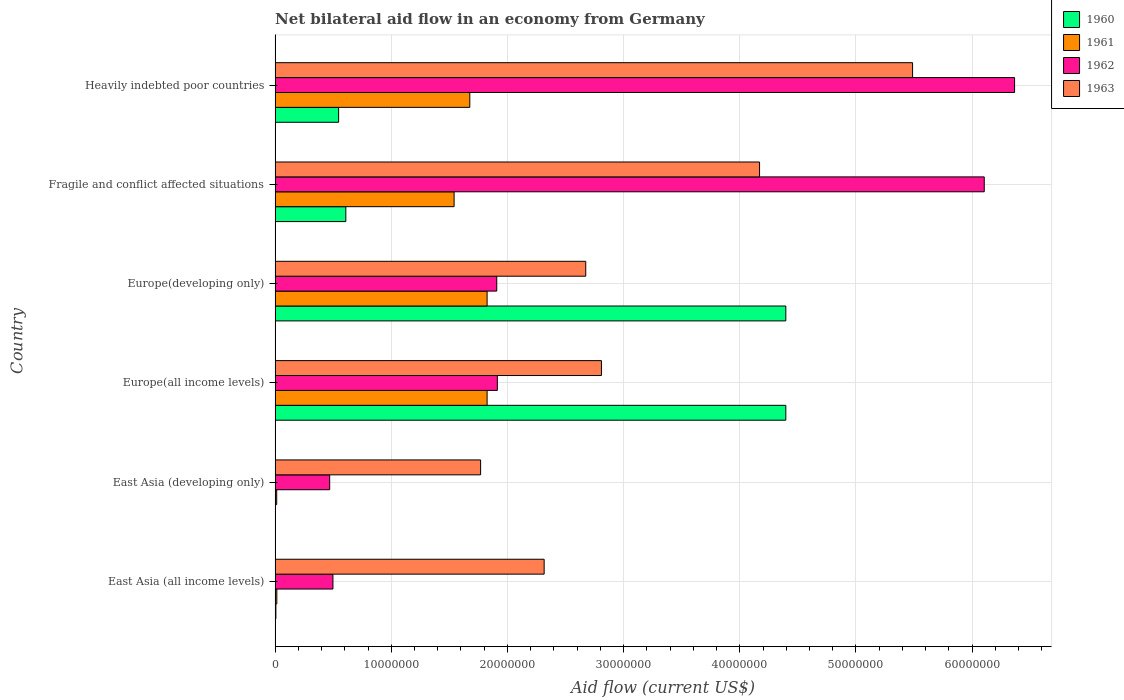Are the number of bars per tick equal to the number of legend labels?
Ensure brevity in your answer.  Yes. How many bars are there on the 2nd tick from the top?
Provide a succinct answer. 4. What is the label of the 3rd group of bars from the top?
Keep it short and to the point. Europe(developing only). In how many cases, is the number of bars for a given country not equal to the number of legend labels?
Keep it short and to the point. 0. Across all countries, what is the maximum net bilateral aid flow in 1963?
Your response must be concise. 5.49e+07. Across all countries, what is the minimum net bilateral aid flow in 1962?
Ensure brevity in your answer.  4.70e+06. In which country was the net bilateral aid flow in 1961 maximum?
Your response must be concise. Europe(all income levels). In which country was the net bilateral aid flow in 1961 minimum?
Make the answer very short. East Asia (developing only). What is the total net bilateral aid flow in 1963 in the graph?
Your answer should be very brief. 1.92e+08. What is the difference between the net bilateral aid flow in 1961 in East Asia (all income levels) and that in Heavily indebted poor countries?
Give a very brief answer. -1.66e+07. What is the difference between the net bilateral aid flow in 1962 in Heavily indebted poor countries and the net bilateral aid flow in 1960 in Fragile and conflict affected situations?
Provide a short and direct response. 5.76e+07. What is the average net bilateral aid flow in 1961 per country?
Provide a succinct answer. 1.15e+07. What is the difference between the net bilateral aid flow in 1962 and net bilateral aid flow in 1961 in East Asia (developing only)?
Offer a very short reply. 4.56e+06. In how many countries, is the net bilateral aid flow in 1963 greater than 42000000 US$?
Give a very brief answer. 1. What is the ratio of the net bilateral aid flow in 1963 in Europe(developing only) to that in Fragile and conflict affected situations?
Ensure brevity in your answer.  0.64. Is the net bilateral aid flow in 1962 in East Asia (all income levels) less than that in Europe(developing only)?
Your response must be concise. Yes. Is the difference between the net bilateral aid flow in 1962 in East Asia (all income levels) and Heavily indebted poor countries greater than the difference between the net bilateral aid flow in 1961 in East Asia (all income levels) and Heavily indebted poor countries?
Offer a terse response. No. What is the difference between the highest and the second highest net bilateral aid flow in 1960?
Your response must be concise. 0. What is the difference between the highest and the lowest net bilateral aid flow in 1962?
Make the answer very short. 5.90e+07. In how many countries, is the net bilateral aid flow in 1963 greater than the average net bilateral aid flow in 1963 taken over all countries?
Give a very brief answer. 2. Is the sum of the net bilateral aid flow in 1962 in East Asia (developing only) and Europe(developing only) greater than the maximum net bilateral aid flow in 1963 across all countries?
Offer a terse response. No. What does the 4th bar from the top in Fragile and conflict affected situations represents?
Your response must be concise. 1960. What does the 2nd bar from the bottom in East Asia (developing only) represents?
Offer a very short reply. 1961. Is it the case that in every country, the sum of the net bilateral aid flow in 1962 and net bilateral aid flow in 1961 is greater than the net bilateral aid flow in 1963?
Your answer should be compact. No. How many countries are there in the graph?
Offer a terse response. 6. What is the difference between two consecutive major ticks on the X-axis?
Offer a very short reply. 1.00e+07. How many legend labels are there?
Provide a succinct answer. 4. How are the legend labels stacked?
Offer a very short reply. Vertical. What is the title of the graph?
Make the answer very short. Net bilateral aid flow in an economy from Germany. Does "1995" appear as one of the legend labels in the graph?
Your response must be concise. No. What is the Aid flow (current US$) of 1961 in East Asia (all income levels)?
Give a very brief answer. 1.50e+05. What is the Aid flow (current US$) in 1962 in East Asia (all income levels)?
Ensure brevity in your answer.  4.98e+06. What is the Aid flow (current US$) of 1963 in East Asia (all income levels)?
Give a very brief answer. 2.32e+07. What is the Aid flow (current US$) of 1960 in East Asia (developing only)?
Offer a terse response. 3.00e+04. What is the Aid flow (current US$) of 1962 in East Asia (developing only)?
Your answer should be compact. 4.70e+06. What is the Aid flow (current US$) of 1963 in East Asia (developing only)?
Your response must be concise. 1.77e+07. What is the Aid flow (current US$) in 1960 in Europe(all income levels)?
Provide a short and direct response. 4.40e+07. What is the Aid flow (current US$) of 1961 in Europe(all income levels)?
Your answer should be compact. 1.82e+07. What is the Aid flow (current US$) of 1962 in Europe(all income levels)?
Make the answer very short. 1.91e+07. What is the Aid flow (current US$) of 1963 in Europe(all income levels)?
Make the answer very short. 2.81e+07. What is the Aid flow (current US$) in 1960 in Europe(developing only)?
Provide a succinct answer. 4.40e+07. What is the Aid flow (current US$) in 1961 in Europe(developing only)?
Keep it short and to the point. 1.82e+07. What is the Aid flow (current US$) of 1962 in Europe(developing only)?
Offer a very short reply. 1.91e+07. What is the Aid flow (current US$) of 1963 in Europe(developing only)?
Keep it short and to the point. 2.67e+07. What is the Aid flow (current US$) of 1960 in Fragile and conflict affected situations?
Your response must be concise. 6.09e+06. What is the Aid flow (current US$) in 1961 in Fragile and conflict affected situations?
Your answer should be compact. 1.54e+07. What is the Aid flow (current US$) of 1962 in Fragile and conflict affected situations?
Offer a very short reply. 6.10e+07. What is the Aid flow (current US$) in 1963 in Fragile and conflict affected situations?
Offer a very short reply. 4.17e+07. What is the Aid flow (current US$) of 1960 in Heavily indebted poor countries?
Your answer should be compact. 5.47e+06. What is the Aid flow (current US$) in 1961 in Heavily indebted poor countries?
Your answer should be very brief. 1.68e+07. What is the Aid flow (current US$) of 1962 in Heavily indebted poor countries?
Keep it short and to the point. 6.36e+07. What is the Aid flow (current US$) of 1963 in Heavily indebted poor countries?
Your response must be concise. 5.49e+07. Across all countries, what is the maximum Aid flow (current US$) of 1960?
Offer a very short reply. 4.40e+07. Across all countries, what is the maximum Aid flow (current US$) of 1961?
Your answer should be very brief. 1.82e+07. Across all countries, what is the maximum Aid flow (current US$) of 1962?
Give a very brief answer. 6.36e+07. Across all countries, what is the maximum Aid flow (current US$) of 1963?
Your answer should be very brief. 5.49e+07. Across all countries, what is the minimum Aid flow (current US$) in 1962?
Offer a terse response. 4.70e+06. Across all countries, what is the minimum Aid flow (current US$) in 1963?
Make the answer very short. 1.77e+07. What is the total Aid flow (current US$) in 1960 in the graph?
Give a very brief answer. 9.96e+07. What is the total Aid flow (current US$) of 1961 in the graph?
Provide a succinct answer. 6.90e+07. What is the total Aid flow (current US$) in 1962 in the graph?
Your response must be concise. 1.73e+08. What is the total Aid flow (current US$) in 1963 in the graph?
Keep it short and to the point. 1.92e+08. What is the difference between the Aid flow (current US$) of 1960 in East Asia (all income levels) and that in East Asia (developing only)?
Give a very brief answer. 4.00e+04. What is the difference between the Aid flow (current US$) in 1962 in East Asia (all income levels) and that in East Asia (developing only)?
Give a very brief answer. 2.80e+05. What is the difference between the Aid flow (current US$) of 1963 in East Asia (all income levels) and that in East Asia (developing only)?
Give a very brief answer. 5.47e+06. What is the difference between the Aid flow (current US$) of 1960 in East Asia (all income levels) and that in Europe(all income levels)?
Your response must be concise. -4.39e+07. What is the difference between the Aid flow (current US$) of 1961 in East Asia (all income levels) and that in Europe(all income levels)?
Your answer should be very brief. -1.81e+07. What is the difference between the Aid flow (current US$) of 1962 in East Asia (all income levels) and that in Europe(all income levels)?
Make the answer very short. -1.42e+07. What is the difference between the Aid flow (current US$) of 1963 in East Asia (all income levels) and that in Europe(all income levels)?
Provide a short and direct response. -4.93e+06. What is the difference between the Aid flow (current US$) in 1960 in East Asia (all income levels) and that in Europe(developing only)?
Give a very brief answer. -4.39e+07. What is the difference between the Aid flow (current US$) of 1961 in East Asia (all income levels) and that in Europe(developing only)?
Your answer should be compact. -1.81e+07. What is the difference between the Aid flow (current US$) of 1962 in East Asia (all income levels) and that in Europe(developing only)?
Provide a succinct answer. -1.41e+07. What is the difference between the Aid flow (current US$) in 1963 in East Asia (all income levels) and that in Europe(developing only)?
Offer a terse response. -3.58e+06. What is the difference between the Aid flow (current US$) in 1960 in East Asia (all income levels) and that in Fragile and conflict affected situations?
Your response must be concise. -6.02e+06. What is the difference between the Aid flow (current US$) in 1961 in East Asia (all income levels) and that in Fragile and conflict affected situations?
Your response must be concise. -1.53e+07. What is the difference between the Aid flow (current US$) of 1962 in East Asia (all income levels) and that in Fragile and conflict affected situations?
Ensure brevity in your answer.  -5.61e+07. What is the difference between the Aid flow (current US$) of 1963 in East Asia (all income levels) and that in Fragile and conflict affected situations?
Your answer should be compact. -1.85e+07. What is the difference between the Aid flow (current US$) in 1960 in East Asia (all income levels) and that in Heavily indebted poor countries?
Your answer should be very brief. -5.40e+06. What is the difference between the Aid flow (current US$) in 1961 in East Asia (all income levels) and that in Heavily indebted poor countries?
Ensure brevity in your answer.  -1.66e+07. What is the difference between the Aid flow (current US$) of 1962 in East Asia (all income levels) and that in Heavily indebted poor countries?
Provide a succinct answer. -5.87e+07. What is the difference between the Aid flow (current US$) of 1963 in East Asia (all income levels) and that in Heavily indebted poor countries?
Your answer should be very brief. -3.17e+07. What is the difference between the Aid flow (current US$) of 1960 in East Asia (developing only) and that in Europe(all income levels)?
Your answer should be very brief. -4.39e+07. What is the difference between the Aid flow (current US$) in 1961 in East Asia (developing only) and that in Europe(all income levels)?
Your answer should be very brief. -1.81e+07. What is the difference between the Aid flow (current US$) of 1962 in East Asia (developing only) and that in Europe(all income levels)?
Make the answer very short. -1.44e+07. What is the difference between the Aid flow (current US$) in 1963 in East Asia (developing only) and that in Europe(all income levels)?
Keep it short and to the point. -1.04e+07. What is the difference between the Aid flow (current US$) of 1960 in East Asia (developing only) and that in Europe(developing only)?
Provide a short and direct response. -4.39e+07. What is the difference between the Aid flow (current US$) of 1961 in East Asia (developing only) and that in Europe(developing only)?
Offer a very short reply. -1.81e+07. What is the difference between the Aid flow (current US$) of 1962 in East Asia (developing only) and that in Europe(developing only)?
Provide a short and direct response. -1.44e+07. What is the difference between the Aid flow (current US$) in 1963 in East Asia (developing only) and that in Europe(developing only)?
Offer a terse response. -9.05e+06. What is the difference between the Aid flow (current US$) in 1960 in East Asia (developing only) and that in Fragile and conflict affected situations?
Your answer should be compact. -6.06e+06. What is the difference between the Aid flow (current US$) of 1961 in East Asia (developing only) and that in Fragile and conflict affected situations?
Provide a succinct answer. -1.53e+07. What is the difference between the Aid flow (current US$) in 1962 in East Asia (developing only) and that in Fragile and conflict affected situations?
Keep it short and to the point. -5.63e+07. What is the difference between the Aid flow (current US$) of 1963 in East Asia (developing only) and that in Fragile and conflict affected situations?
Ensure brevity in your answer.  -2.40e+07. What is the difference between the Aid flow (current US$) of 1960 in East Asia (developing only) and that in Heavily indebted poor countries?
Provide a short and direct response. -5.44e+06. What is the difference between the Aid flow (current US$) of 1961 in East Asia (developing only) and that in Heavily indebted poor countries?
Provide a succinct answer. -1.66e+07. What is the difference between the Aid flow (current US$) of 1962 in East Asia (developing only) and that in Heavily indebted poor countries?
Ensure brevity in your answer.  -5.90e+07. What is the difference between the Aid flow (current US$) in 1963 in East Asia (developing only) and that in Heavily indebted poor countries?
Provide a succinct answer. -3.72e+07. What is the difference between the Aid flow (current US$) of 1961 in Europe(all income levels) and that in Europe(developing only)?
Keep it short and to the point. 0. What is the difference between the Aid flow (current US$) of 1962 in Europe(all income levels) and that in Europe(developing only)?
Your answer should be compact. 5.00e+04. What is the difference between the Aid flow (current US$) of 1963 in Europe(all income levels) and that in Europe(developing only)?
Your response must be concise. 1.35e+06. What is the difference between the Aid flow (current US$) in 1960 in Europe(all income levels) and that in Fragile and conflict affected situations?
Provide a succinct answer. 3.79e+07. What is the difference between the Aid flow (current US$) of 1961 in Europe(all income levels) and that in Fragile and conflict affected situations?
Your answer should be very brief. 2.84e+06. What is the difference between the Aid flow (current US$) of 1962 in Europe(all income levels) and that in Fragile and conflict affected situations?
Offer a terse response. -4.19e+07. What is the difference between the Aid flow (current US$) in 1963 in Europe(all income levels) and that in Fragile and conflict affected situations?
Offer a very short reply. -1.36e+07. What is the difference between the Aid flow (current US$) in 1960 in Europe(all income levels) and that in Heavily indebted poor countries?
Provide a succinct answer. 3.85e+07. What is the difference between the Aid flow (current US$) in 1961 in Europe(all income levels) and that in Heavily indebted poor countries?
Provide a short and direct response. 1.49e+06. What is the difference between the Aid flow (current US$) of 1962 in Europe(all income levels) and that in Heavily indebted poor countries?
Ensure brevity in your answer.  -4.45e+07. What is the difference between the Aid flow (current US$) of 1963 in Europe(all income levels) and that in Heavily indebted poor countries?
Give a very brief answer. -2.68e+07. What is the difference between the Aid flow (current US$) of 1960 in Europe(developing only) and that in Fragile and conflict affected situations?
Ensure brevity in your answer.  3.79e+07. What is the difference between the Aid flow (current US$) in 1961 in Europe(developing only) and that in Fragile and conflict affected situations?
Ensure brevity in your answer.  2.84e+06. What is the difference between the Aid flow (current US$) in 1962 in Europe(developing only) and that in Fragile and conflict affected situations?
Offer a very short reply. -4.20e+07. What is the difference between the Aid flow (current US$) in 1963 in Europe(developing only) and that in Fragile and conflict affected situations?
Offer a terse response. -1.50e+07. What is the difference between the Aid flow (current US$) of 1960 in Europe(developing only) and that in Heavily indebted poor countries?
Make the answer very short. 3.85e+07. What is the difference between the Aid flow (current US$) of 1961 in Europe(developing only) and that in Heavily indebted poor countries?
Give a very brief answer. 1.49e+06. What is the difference between the Aid flow (current US$) in 1962 in Europe(developing only) and that in Heavily indebted poor countries?
Keep it short and to the point. -4.46e+07. What is the difference between the Aid flow (current US$) in 1963 in Europe(developing only) and that in Heavily indebted poor countries?
Provide a short and direct response. -2.81e+07. What is the difference between the Aid flow (current US$) of 1960 in Fragile and conflict affected situations and that in Heavily indebted poor countries?
Offer a terse response. 6.20e+05. What is the difference between the Aid flow (current US$) of 1961 in Fragile and conflict affected situations and that in Heavily indebted poor countries?
Keep it short and to the point. -1.35e+06. What is the difference between the Aid flow (current US$) in 1962 in Fragile and conflict affected situations and that in Heavily indebted poor countries?
Give a very brief answer. -2.61e+06. What is the difference between the Aid flow (current US$) of 1963 in Fragile and conflict affected situations and that in Heavily indebted poor countries?
Make the answer very short. -1.32e+07. What is the difference between the Aid flow (current US$) of 1960 in East Asia (all income levels) and the Aid flow (current US$) of 1962 in East Asia (developing only)?
Provide a succinct answer. -4.63e+06. What is the difference between the Aid flow (current US$) in 1960 in East Asia (all income levels) and the Aid flow (current US$) in 1963 in East Asia (developing only)?
Your answer should be compact. -1.76e+07. What is the difference between the Aid flow (current US$) in 1961 in East Asia (all income levels) and the Aid flow (current US$) in 1962 in East Asia (developing only)?
Provide a succinct answer. -4.55e+06. What is the difference between the Aid flow (current US$) in 1961 in East Asia (all income levels) and the Aid flow (current US$) in 1963 in East Asia (developing only)?
Make the answer very short. -1.75e+07. What is the difference between the Aid flow (current US$) of 1962 in East Asia (all income levels) and the Aid flow (current US$) of 1963 in East Asia (developing only)?
Your response must be concise. -1.27e+07. What is the difference between the Aid flow (current US$) of 1960 in East Asia (all income levels) and the Aid flow (current US$) of 1961 in Europe(all income levels)?
Make the answer very short. -1.82e+07. What is the difference between the Aid flow (current US$) in 1960 in East Asia (all income levels) and the Aid flow (current US$) in 1962 in Europe(all income levels)?
Give a very brief answer. -1.91e+07. What is the difference between the Aid flow (current US$) in 1960 in East Asia (all income levels) and the Aid flow (current US$) in 1963 in Europe(all income levels)?
Make the answer very short. -2.80e+07. What is the difference between the Aid flow (current US$) of 1961 in East Asia (all income levels) and the Aid flow (current US$) of 1962 in Europe(all income levels)?
Make the answer very short. -1.90e+07. What is the difference between the Aid flow (current US$) in 1961 in East Asia (all income levels) and the Aid flow (current US$) in 1963 in Europe(all income levels)?
Ensure brevity in your answer.  -2.79e+07. What is the difference between the Aid flow (current US$) of 1962 in East Asia (all income levels) and the Aid flow (current US$) of 1963 in Europe(all income levels)?
Offer a terse response. -2.31e+07. What is the difference between the Aid flow (current US$) of 1960 in East Asia (all income levels) and the Aid flow (current US$) of 1961 in Europe(developing only)?
Keep it short and to the point. -1.82e+07. What is the difference between the Aid flow (current US$) of 1960 in East Asia (all income levels) and the Aid flow (current US$) of 1962 in Europe(developing only)?
Your answer should be very brief. -1.90e+07. What is the difference between the Aid flow (current US$) in 1960 in East Asia (all income levels) and the Aid flow (current US$) in 1963 in Europe(developing only)?
Ensure brevity in your answer.  -2.67e+07. What is the difference between the Aid flow (current US$) of 1961 in East Asia (all income levels) and the Aid flow (current US$) of 1962 in Europe(developing only)?
Provide a short and direct response. -1.89e+07. What is the difference between the Aid flow (current US$) in 1961 in East Asia (all income levels) and the Aid flow (current US$) in 1963 in Europe(developing only)?
Ensure brevity in your answer.  -2.66e+07. What is the difference between the Aid flow (current US$) of 1962 in East Asia (all income levels) and the Aid flow (current US$) of 1963 in Europe(developing only)?
Keep it short and to the point. -2.18e+07. What is the difference between the Aid flow (current US$) in 1960 in East Asia (all income levels) and the Aid flow (current US$) in 1961 in Fragile and conflict affected situations?
Your answer should be very brief. -1.53e+07. What is the difference between the Aid flow (current US$) of 1960 in East Asia (all income levels) and the Aid flow (current US$) of 1962 in Fragile and conflict affected situations?
Give a very brief answer. -6.10e+07. What is the difference between the Aid flow (current US$) in 1960 in East Asia (all income levels) and the Aid flow (current US$) in 1963 in Fragile and conflict affected situations?
Your answer should be very brief. -4.16e+07. What is the difference between the Aid flow (current US$) of 1961 in East Asia (all income levels) and the Aid flow (current US$) of 1962 in Fragile and conflict affected situations?
Keep it short and to the point. -6.09e+07. What is the difference between the Aid flow (current US$) of 1961 in East Asia (all income levels) and the Aid flow (current US$) of 1963 in Fragile and conflict affected situations?
Your answer should be compact. -4.16e+07. What is the difference between the Aid flow (current US$) of 1962 in East Asia (all income levels) and the Aid flow (current US$) of 1963 in Fragile and conflict affected situations?
Make the answer very short. -3.67e+07. What is the difference between the Aid flow (current US$) in 1960 in East Asia (all income levels) and the Aid flow (current US$) in 1961 in Heavily indebted poor countries?
Your answer should be compact. -1.67e+07. What is the difference between the Aid flow (current US$) of 1960 in East Asia (all income levels) and the Aid flow (current US$) of 1962 in Heavily indebted poor countries?
Provide a short and direct response. -6.36e+07. What is the difference between the Aid flow (current US$) in 1960 in East Asia (all income levels) and the Aid flow (current US$) in 1963 in Heavily indebted poor countries?
Ensure brevity in your answer.  -5.48e+07. What is the difference between the Aid flow (current US$) in 1961 in East Asia (all income levels) and the Aid flow (current US$) in 1962 in Heavily indebted poor countries?
Provide a short and direct response. -6.35e+07. What is the difference between the Aid flow (current US$) of 1961 in East Asia (all income levels) and the Aid flow (current US$) of 1963 in Heavily indebted poor countries?
Your answer should be compact. -5.47e+07. What is the difference between the Aid flow (current US$) of 1962 in East Asia (all income levels) and the Aid flow (current US$) of 1963 in Heavily indebted poor countries?
Make the answer very short. -4.99e+07. What is the difference between the Aid flow (current US$) in 1960 in East Asia (developing only) and the Aid flow (current US$) in 1961 in Europe(all income levels)?
Keep it short and to the point. -1.82e+07. What is the difference between the Aid flow (current US$) of 1960 in East Asia (developing only) and the Aid flow (current US$) of 1962 in Europe(all income levels)?
Your response must be concise. -1.91e+07. What is the difference between the Aid flow (current US$) of 1960 in East Asia (developing only) and the Aid flow (current US$) of 1963 in Europe(all income levels)?
Your answer should be very brief. -2.81e+07. What is the difference between the Aid flow (current US$) of 1961 in East Asia (developing only) and the Aid flow (current US$) of 1962 in Europe(all income levels)?
Provide a succinct answer. -1.90e+07. What is the difference between the Aid flow (current US$) in 1961 in East Asia (developing only) and the Aid flow (current US$) in 1963 in Europe(all income levels)?
Your answer should be compact. -2.80e+07. What is the difference between the Aid flow (current US$) of 1962 in East Asia (developing only) and the Aid flow (current US$) of 1963 in Europe(all income levels)?
Your answer should be very brief. -2.34e+07. What is the difference between the Aid flow (current US$) in 1960 in East Asia (developing only) and the Aid flow (current US$) in 1961 in Europe(developing only)?
Offer a very short reply. -1.82e+07. What is the difference between the Aid flow (current US$) in 1960 in East Asia (developing only) and the Aid flow (current US$) in 1962 in Europe(developing only)?
Keep it short and to the point. -1.90e+07. What is the difference between the Aid flow (current US$) of 1960 in East Asia (developing only) and the Aid flow (current US$) of 1963 in Europe(developing only)?
Make the answer very short. -2.67e+07. What is the difference between the Aid flow (current US$) of 1961 in East Asia (developing only) and the Aid flow (current US$) of 1962 in Europe(developing only)?
Offer a terse response. -1.89e+07. What is the difference between the Aid flow (current US$) in 1961 in East Asia (developing only) and the Aid flow (current US$) in 1963 in Europe(developing only)?
Your answer should be compact. -2.66e+07. What is the difference between the Aid flow (current US$) in 1962 in East Asia (developing only) and the Aid flow (current US$) in 1963 in Europe(developing only)?
Your response must be concise. -2.20e+07. What is the difference between the Aid flow (current US$) in 1960 in East Asia (developing only) and the Aid flow (current US$) in 1961 in Fragile and conflict affected situations?
Ensure brevity in your answer.  -1.54e+07. What is the difference between the Aid flow (current US$) in 1960 in East Asia (developing only) and the Aid flow (current US$) in 1962 in Fragile and conflict affected situations?
Provide a short and direct response. -6.10e+07. What is the difference between the Aid flow (current US$) of 1960 in East Asia (developing only) and the Aid flow (current US$) of 1963 in Fragile and conflict affected situations?
Offer a very short reply. -4.17e+07. What is the difference between the Aid flow (current US$) in 1961 in East Asia (developing only) and the Aid flow (current US$) in 1962 in Fragile and conflict affected situations?
Offer a terse response. -6.09e+07. What is the difference between the Aid flow (current US$) of 1961 in East Asia (developing only) and the Aid flow (current US$) of 1963 in Fragile and conflict affected situations?
Offer a terse response. -4.16e+07. What is the difference between the Aid flow (current US$) in 1962 in East Asia (developing only) and the Aid flow (current US$) in 1963 in Fragile and conflict affected situations?
Keep it short and to the point. -3.70e+07. What is the difference between the Aid flow (current US$) of 1960 in East Asia (developing only) and the Aid flow (current US$) of 1961 in Heavily indebted poor countries?
Ensure brevity in your answer.  -1.67e+07. What is the difference between the Aid flow (current US$) of 1960 in East Asia (developing only) and the Aid flow (current US$) of 1962 in Heavily indebted poor countries?
Provide a succinct answer. -6.36e+07. What is the difference between the Aid flow (current US$) in 1960 in East Asia (developing only) and the Aid flow (current US$) in 1963 in Heavily indebted poor countries?
Your answer should be very brief. -5.48e+07. What is the difference between the Aid flow (current US$) in 1961 in East Asia (developing only) and the Aid flow (current US$) in 1962 in Heavily indebted poor countries?
Provide a succinct answer. -6.35e+07. What is the difference between the Aid flow (current US$) of 1961 in East Asia (developing only) and the Aid flow (current US$) of 1963 in Heavily indebted poor countries?
Offer a very short reply. -5.47e+07. What is the difference between the Aid flow (current US$) in 1962 in East Asia (developing only) and the Aid flow (current US$) in 1963 in Heavily indebted poor countries?
Give a very brief answer. -5.02e+07. What is the difference between the Aid flow (current US$) in 1960 in Europe(all income levels) and the Aid flow (current US$) in 1961 in Europe(developing only)?
Provide a succinct answer. 2.57e+07. What is the difference between the Aid flow (current US$) in 1960 in Europe(all income levels) and the Aid flow (current US$) in 1962 in Europe(developing only)?
Your response must be concise. 2.49e+07. What is the difference between the Aid flow (current US$) of 1960 in Europe(all income levels) and the Aid flow (current US$) of 1963 in Europe(developing only)?
Offer a terse response. 1.72e+07. What is the difference between the Aid flow (current US$) in 1961 in Europe(all income levels) and the Aid flow (current US$) in 1962 in Europe(developing only)?
Ensure brevity in your answer.  -8.30e+05. What is the difference between the Aid flow (current US$) in 1961 in Europe(all income levels) and the Aid flow (current US$) in 1963 in Europe(developing only)?
Your answer should be very brief. -8.49e+06. What is the difference between the Aid flow (current US$) of 1962 in Europe(all income levels) and the Aid flow (current US$) of 1963 in Europe(developing only)?
Ensure brevity in your answer.  -7.61e+06. What is the difference between the Aid flow (current US$) in 1960 in Europe(all income levels) and the Aid flow (current US$) in 1961 in Fragile and conflict affected situations?
Your response must be concise. 2.86e+07. What is the difference between the Aid flow (current US$) in 1960 in Europe(all income levels) and the Aid flow (current US$) in 1962 in Fragile and conflict affected situations?
Make the answer very short. -1.71e+07. What is the difference between the Aid flow (current US$) of 1960 in Europe(all income levels) and the Aid flow (current US$) of 1963 in Fragile and conflict affected situations?
Your response must be concise. 2.26e+06. What is the difference between the Aid flow (current US$) of 1961 in Europe(all income levels) and the Aid flow (current US$) of 1962 in Fragile and conflict affected situations?
Your answer should be very brief. -4.28e+07. What is the difference between the Aid flow (current US$) in 1961 in Europe(all income levels) and the Aid flow (current US$) in 1963 in Fragile and conflict affected situations?
Give a very brief answer. -2.34e+07. What is the difference between the Aid flow (current US$) of 1962 in Europe(all income levels) and the Aid flow (current US$) of 1963 in Fragile and conflict affected situations?
Give a very brief answer. -2.26e+07. What is the difference between the Aid flow (current US$) in 1960 in Europe(all income levels) and the Aid flow (current US$) in 1961 in Heavily indebted poor countries?
Ensure brevity in your answer.  2.72e+07. What is the difference between the Aid flow (current US$) in 1960 in Europe(all income levels) and the Aid flow (current US$) in 1962 in Heavily indebted poor countries?
Your answer should be compact. -1.97e+07. What is the difference between the Aid flow (current US$) in 1960 in Europe(all income levels) and the Aid flow (current US$) in 1963 in Heavily indebted poor countries?
Provide a succinct answer. -1.09e+07. What is the difference between the Aid flow (current US$) of 1961 in Europe(all income levels) and the Aid flow (current US$) of 1962 in Heavily indebted poor countries?
Make the answer very short. -4.54e+07. What is the difference between the Aid flow (current US$) in 1961 in Europe(all income levels) and the Aid flow (current US$) in 1963 in Heavily indebted poor countries?
Offer a very short reply. -3.66e+07. What is the difference between the Aid flow (current US$) of 1962 in Europe(all income levels) and the Aid flow (current US$) of 1963 in Heavily indebted poor countries?
Your answer should be very brief. -3.57e+07. What is the difference between the Aid flow (current US$) of 1960 in Europe(developing only) and the Aid flow (current US$) of 1961 in Fragile and conflict affected situations?
Make the answer very short. 2.86e+07. What is the difference between the Aid flow (current US$) of 1960 in Europe(developing only) and the Aid flow (current US$) of 1962 in Fragile and conflict affected situations?
Your response must be concise. -1.71e+07. What is the difference between the Aid flow (current US$) of 1960 in Europe(developing only) and the Aid flow (current US$) of 1963 in Fragile and conflict affected situations?
Give a very brief answer. 2.26e+06. What is the difference between the Aid flow (current US$) in 1961 in Europe(developing only) and the Aid flow (current US$) in 1962 in Fragile and conflict affected situations?
Offer a very short reply. -4.28e+07. What is the difference between the Aid flow (current US$) in 1961 in Europe(developing only) and the Aid flow (current US$) in 1963 in Fragile and conflict affected situations?
Your response must be concise. -2.34e+07. What is the difference between the Aid flow (current US$) in 1962 in Europe(developing only) and the Aid flow (current US$) in 1963 in Fragile and conflict affected situations?
Your answer should be very brief. -2.26e+07. What is the difference between the Aid flow (current US$) of 1960 in Europe(developing only) and the Aid flow (current US$) of 1961 in Heavily indebted poor countries?
Offer a terse response. 2.72e+07. What is the difference between the Aid flow (current US$) of 1960 in Europe(developing only) and the Aid flow (current US$) of 1962 in Heavily indebted poor countries?
Offer a very short reply. -1.97e+07. What is the difference between the Aid flow (current US$) of 1960 in Europe(developing only) and the Aid flow (current US$) of 1963 in Heavily indebted poor countries?
Provide a succinct answer. -1.09e+07. What is the difference between the Aid flow (current US$) in 1961 in Europe(developing only) and the Aid flow (current US$) in 1962 in Heavily indebted poor countries?
Make the answer very short. -4.54e+07. What is the difference between the Aid flow (current US$) in 1961 in Europe(developing only) and the Aid flow (current US$) in 1963 in Heavily indebted poor countries?
Make the answer very short. -3.66e+07. What is the difference between the Aid flow (current US$) of 1962 in Europe(developing only) and the Aid flow (current US$) of 1963 in Heavily indebted poor countries?
Offer a terse response. -3.58e+07. What is the difference between the Aid flow (current US$) of 1960 in Fragile and conflict affected situations and the Aid flow (current US$) of 1961 in Heavily indebted poor countries?
Make the answer very short. -1.07e+07. What is the difference between the Aid flow (current US$) of 1960 in Fragile and conflict affected situations and the Aid flow (current US$) of 1962 in Heavily indebted poor countries?
Your answer should be compact. -5.76e+07. What is the difference between the Aid flow (current US$) of 1960 in Fragile and conflict affected situations and the Aid flow (current US$) of 1963 in Heavily indebted poor countries?
Your response must be concise. -4.88e+07. What is the difference between the Aid flow (current US$) of 1961 in Fragile and conflict affected situations and the Aid flow (current US$) of 1962 in Heavily indebted poor countries?
Ensure brevity in your answer.  -4.82e+07. What is the difference between the Aid flow (current US$) of 1961 in Fragile and conflict affected situations and the Aid flow (current US$) of 1963 in Heavily indebted poor countries?
Give a very brief answer. -3.95e+07. What is the difference between the Aid flow (current US$) of 1962 in Fragile and conflict affected situations and the Aid flow (current US$) of 1963 in Heavily indebted poor countries?
Your response must be concise. 6.17e+06. What is the average Aid flow (current US$) in 1960 per country?
Your answer should be very brief. 1.66e+07. What is the average Aid flow (current US$) of 1961 per country?
Offer a very short reply. 1.15e+07. What is the average Aid flow (current US$) of 1962 per country?
Your answer should be very brief. 2.88e+07. What is the average Aid flow (current US$) in 1963 per country?
Offer a very short reply. 3.20e+07. What is the difference between the Aid flow (current US$) in 1960 and Aid flow (current US$) in 1962 in East Asia (all income levels)?
Your answer should be very brief. -4.91e+06. What is the difference between the Aid flow (current US$) in 1960 and Aid flow (current US$) in 1963 in East Asia (all income levels)?
Provide a succinct answer. -2.31e+07. What is the difference between the Aid flow (current US$) in 1961 and Aid flow (current US$) in 1962 in East Asia (all income levels)?
Ensure brevity in your answer.  -4.83e+06. What is the difference between the Aid flow (current US$) in 1961 and Aid flow (current US$) in 1963 in East Asia (all income levels)?
Ensure brevity in your answer.  -2.30e+07. What is the difference between the Aid flow (current US$) of 1962 and Aid flow (current US$) of 1963 in East Asia (all income levels)?
Your answer should be compact. -1.82e+07. What is the difference between the Aid flow (current US$) of 1960 and Aid flow (current US$) of 1961 in East Asia (developing only)?
Your response must be concise. -1.10e+05. What is the difference between the Aid flow (current US$) in 1960 and Aid flow (current US$) in 1962 in East Asia (developing only)?
Give a very brief answer. -4.67e+06. What is the difference between the Aid flow (current US$) in 1960 and Aid flow (current US$) in 1963 in East Asia (developing only)?
Give a very brief answer. -1.77e+07. What is the difference between the Aid flow (current US$) of 1961 and Aid flow (current US$) of 1962 in East Asia (developing only)?
Provide a succinct answer. -4.56e+06. What is the difference between the Aid flow (current US$) in 1961 and Aid flow (current US$) in 1963 in East Asia (developing only)?
Your answer should be compact. -1.76e+07. What is the difference between the Aid flow (current US$) in 1962 and Aid flow (current US$) in 1963 in East Asia (developing only)?
Your response must be concise. -1.30e+07. What is the difference between the Aid flow (current US$) of 1960 and Aid flow (current US$) of 1961 in Europe(all income levels)?
Provide a succinct answer. 2.57e+07. What is the difference between the Aid flow (current US$) of 1960 and Aid flow (current US$) of 1962 in Europe(all income levels)?
Give a very brief answer. 2.48e+07. What is the difference between the Aid flow (current US$) of 1960 and Aid flow (current US$) of 1963 in Europe(all income levels)?
Give a very brief answer. 1.59e+07. What is the difference between the Aid flow (current US$) in 1961 and Aid flow (current US$) in 1962 in Europe(all income levels)?
Ensure brevity in your answer.  -8.80e+05. What is the difference between the Aid flow (current US$) in 1961 and Aid flow (current US$) in 1963 in Europe(all income levels)?
Make the answer very short. -9.84e+06. What is the difference between the Aid flow (current US$) in 1962 and Aid flow (current US$) in 1963 in Europe(all income levels)?
Keep it short and to the point. -8.96e+06. What is the difference between the Aid flow (current US$) of 1960 and Aid flow (current US$) of 1961 in Europe(developing only)?
Ensure brevity in your answer.  2.57e+07. What is the difference between the Aid flow (current US$) in 1960 and Aid flow (current US$) in 1962 in Europe(developing only)?
Make the answer very short. 2.49e+07. What is the difference between the Aid flow (current US$) of 1960 and Aid flow (current US$) of 1963 in Europe(developing only)?
Make the answer very short. 1.72e+07. What is the difference between the Aid flow (current US$) in 1961 and Aid flow (current US$) in 1962 in Europe(developing only)?
Your answer should be very brief. -8.30e+05. What is the difference between the Aid flow (current US$) of 1961 and Aid flow (current US$) of 1963 in Europe(developing only)?
Make the answer very short. -8.49e+06. What is the difference between the Aid flow (current US$) of 1962 and Aid flow (current US$) of 1963 in Europe(developing only)?
Provide a succinct answer. -7.66e+06. What is the difference between the Aid flow (current US$) of 1960 and Aid flow (current US$) of 1961 in Fragile and conflict affected situations?
Make the answer very short. -9.32e+06. What is the difference between the Aid flow (current US$) in 1960 and Aid flow (current US$) in 1962 in Fragile and conflict affected situations?
Provide a succinct answer. -5.50e+07. What is the difference between the Aid flow (current US$) in 1960 and Aid flow (current US$) in 1963 in Fragile and conflict affected situations?
Make the answer very short. -3.56e+07. What is the difference between the Aid flow (current US$) of 1961 and Aid flow (current US$) of 1962 in Fragile and conflict affected situations?
Offer a very short reply. -4.56e+07. What is the difference between the Aid flow (current US$) of 1961 and Aid flow (current US$) of 1963 in Fragile and conflict affected situations?
Provide a short and direct response. -2.63e+07. What is the difference between the Aid flow (current US$) in 1962 and Aid flow (current US$) in 1963 in Fragile and conflict affected situations?
Ensure brevity in your answer.  1.93e+07. What is the difference between the Aid flow (current US$) of 1960 and Aid flow (current US$) of 1961 in Heavily indebted poor countries?
Give a very brief answer. -1.13e+07. What is the difference between the Aid flow (current US$) of 1960 and Aid flow (current US$) of 1962 in Heavily indebted poor countries?
Keep it short and to the point. -5.82e+07. What is the difference between the Aid flow (current US$) in 1960 and Aid flow (current US$) in 1963 in Heavily indebted poor countries?
Offer a terse response. -4.94e+07. What is the difference between the Aid flow (current US$) in 1961 and Aid flow (current US$) in 1962 in Heavily indebted poor countries?
Keep it short and to the point. -4.69e+07. What is the difference between the Aid flow (current US$) of 1961 and Aid flow (current US$) of 1963 in Heavily indebted poor countries?
Give a very brief answer. -3.81e+07. What is the difference between the Aid flow (current US$) of 1962 and Aid flow (current US$) of 1963 in Heavily indebted poor countries?
Your answer should be compact. 8.78e+06. What is the ratio of the Aid flow (current US$) in 1960 in East Asia (all income levels) to that in East Asia (developing only)?
Offer a very short reply. 2.33. What is the ratio of the Aid flow (current US$) in 1961 in East Asia (all income levels) to that in East Asia (developing only)?
Offer a very short reply. 1.07. What is the ratio of the Aid flow (current US$) of 1962 in East Asia (all income levels) to that in East Asia (developing only)?
Your answer should be compact. 1.06. What is the ratio of the Aid flow (current US$) in 1963 in East Asia (all income levels) to that in East Asia (developing only)?
Your answer should be very brief. 1.31. What is the ratio of the Aid flow (current US$) in 1960 in East Asia (all income levels) to that in Europe(all income levels)?
Make the answer very short. 0. What is the ratio of the Aid flow (current US$) of 1961 in East Asia (all income levels) to that in Europe(all income levels)?
Provide a short and direct response. 0.01. What is the ratio of the Aid flow (current US$) in 1962 in East Asia (all income levels) to that in Europe(all income levels)?
Make the answer very short. 0.26. What is the ratio of the Aid flow (current US$) in 1963 in East Asia (all income levels) to that in Europe(all income levels)?
Keep it short and to the point. 0.82. What is the ratio of the Aid flow (current US$) of 1960 in East Asia (all income levels) to that in Europe(developing only)?
Offer a very short reply. 0. What is the ratio of the Aid flow (current US$) of 1961 in East Asia (all income levels) to that in Europe(developing only)?
Ensure brevity in your answer.  0.01. What is the ratio of the Aid flow (current US$) in 1962 in East Asia (all income levels) to that in Europe(developing only)?
Ensure brevity in your answer.  0.26. What is the ratio of the Aid flow (current US$) of 1963 in East Asia (all income levels) to that in Europe(developing only)?
Ensure brevity in your answer.  0.87. What is the ratio of the Aid flow (current US$) of 1960 in East Asia (all income levels) to that in Fragile and conflict affected situations?
Your response must be concise. 0.01. What is the ratio of the Aid flow (current US$) of 1961 in East Asia (all income levels) to that in Fragile and conflict affected situations?
Provide a short and direct response. 0.01. What is the ratio of the Aid flow (current US$) in 1962 in East Asia (all income levels) to that in Fragile and conflict affected situations?
Your answer should be compact. 0.08. What is the ratio of the Aid flow (current US$) in 1963 in East Asia (all income levels) to that in Fragile and conflict affected situations?
Offer a terse response. 0.56. What is the ratio of the Aid flow (current US$) in 1960 in East Asia (all income levels) to that in Heavily indebted poor countries?
Provide a short and direct response. 0.01. What is the ratio of the Aid flow (current US$) in 1961 in East Asia (all income levels) to that in Heavily indebted poor countries?
Give a very brief answer. 0.01. What is the ratio of the Aid flow (current US$) in 1962 in East Asia (all income levels) to that in Heavily indebted poor countries?
Provide a short and direct response. 0.08. What is the ratio of the Aid flow (current US$) in 1963 in East Asia (all income levels) to that in Heavily indebted poor countries?
Offer a terse response. 0.42. What is the ratio of the Aid flow (current US$) of 1960 in East Asia (developing only) to that in Europe(all income levels)?
Your response must be concise. 0. What is the ratio of the Aid flow (current US$) in 1961 in East Asia (developing only) to that in Europe(all income levels)?
Give a very brief answer. 0.01. What is the ratio of the Aid flow (current US$) in 1962 in East Asia (developing only) to that in Europe(all income levels)?
Provide a short and direct response. 0.25. What is the ratio of the Aid flow (current US$) in 1963 in East Asia (developing only) to that in Europe(all income levels)?
Provide a succinct answer. 0.63. What is the ratio of the Aid flow (current US$) of 1960 in East Asia (developing only) to that in Europe(developing only)?
Offer a terse response. 0. What is the ratio of the Aid flow (current US$) of 1961 in East Asia (developing only) to that in Europe(developing only)?
Your response must be concise. 0.01. What is the ratio of the Aid flow (current US$) of 1962 in East Asia (developing only) to that in Europe(developing only)?
Provide a short and direct response. 0.25. What is the ratio of the Aid flow (current US$) in 1963 in East Asia (developing only) to that in Europe(developing only)?
Make the answer very short. 0.66. What is the ratio of the Aid flow (current US$) of 1960 in East Asia (developing only) to that in Fragile and conflict affected situations?
Provide a succinct answer. 0. What is the ratio of the Aid flow (current US$) in 1961 in East Asia (developing only) to that in Fragile and conflict affected situations?
Make the answer very short. 0.01. What is the ratio of the Aid flow (current US$) of 1962 in East Asia (developing only) to that in Fragile and conflict affected situations?
Offer a terse response. 0.08. What is the ratio of the Aid flow (current US$) in 1963 in East Asia (developing only) to that in Fragile and conflict affected situations?
Your response must be concise. 0.42. What is the ratio of the Aid flow (current US$) in 1960 in East Asia (developing only) to that in Heavily indebted poor countries?
Give a very brief answer. 0.01. What is the ratio of the Aid flow (current US$) in 1961 in East Asia (developing only) to that in Heavily indebted poor countries?
Your answer should be very brief. 0.01. What is the ratio of the Aid flow (current US$) of 1962 in East Asia (developing only) to that in Heavily indebted poor countries?
Provide a short and direct response. 0.07. What is the ratio of the Aid flow (current US$) of 1963 in East Asia (developing only) to that in Heavily indebted poor countries?
Provide a short and direct response. 0.32. What is the ratio of the Aid flow (current US$) in 1961 in Europe(all income levels) to that in Europe(developing only)?
Provide a succinct answer. 1. What is the ratio of the Aid flow (current US$) in 1962 in Europe(all income levels) to that in Europe(developing only)?
Provide a succinct answer. 1. What is the ratio of the Aid flow (current US$) in 1963 in Europe(all income levels) to that in Europe(developing only)?
Ensure brevity in your answer.  1.05. What is the ratio of the Aid flow (current US$) in 1960 in Europe(all income levels) to that in Fragile and conflict affected situations?
Offer a terse response. 7.22. What is the ratio of the Aid flow (current US$) in 1961 in Europe(all income levels) to that in Fragile and conflict affected situations?
Provide a succinct answer. 1.18. What is the ratio of the Aid flow (current US$) of 1962 in Europe(all income levels) to that in Fragile and conflict affected situations?
Provide a short and direct response. 0.31. What is the ratio of the Aid flow (current US$) in 1963 in Europe(all income levels) to that in Fragile and conflict affected situations?
Offer a terse response. 0.67. What is the ratio of the Aid flow (current US$) in 1960 in Europe(all income levels) to that in Heavily indebted poor countries?
Your response must be concise. 8.04. What is the ratio of the Aid flow (current US$) in 1961 in Europe(all income levels) to that in Heavily indebted poor countries?
Offer a terse response. 1.09. What is the ratio of the Aid flow (current US$) of 1962 in Europe(all income levels) to that in Heavily indebted poor countries?
Give a very brief answer. 0.3. What is the ratio of the Aid flow (current US$) in 1963 in Europe(all income levels) to that in Heavily indebted poor countries?
Your response must be concise. 0.51. What is the ratio of the Aid flow (current US$) of 1960 in Europe(developing only) to that in Fragile and conflict affected situations?
Your answer should be very brief. 7.22. What is the ratio of the Aid flow (current US$) in 1961 in Europe(developing only) to that in Fragile and conflict affected situations?
Your response must be concise. 1.18. What is the ratio of the Aid flow (current US$) of 1962 in Europe(developing only) to that in Fragile and conflict affected situations?
Your response must be concise. 0.31. What is the ratio of the Aid flow (current US$) of 1963 in Europe(developing only) to that in Fragile and conflict affected situations?
Make the answer very short. 0.64. What is the ratio of the Aid flow (current US$) of 1960 in Europe(developing only) to that in Heavily indebted poor countries?
Offer a terse response. 8.04. What is the ratio of the Aid flow (current US$) in 1961 in Europe(developing only) to that in Heavily indebted poor countries?
Offer a terse response. 1.09. What is the ratio of the Aid flow (current US$) of 1962 in Europe(developing only) to that in Heavily indebted poor countries?
Offer a terse response. 0.3. What is the ratio of the Aid flow (current US$) of 1963 in Europe(developing only) to that in Heavily indebted poor countries?
Your answer should be very brief. 0.49. What is the ratio of the Aid flow (current US$) of 1960 in Fragile and conflict affected situations to that in Heavily indebted poor countries?
Provide a succinct answer. 1.11. What is the ratio of the Aid flow (current US$) in 1961 in Fragile and conflict affected situations to that in Heavily indebted poor countries?
Keep it short and to the point. 0.92. What is the ratio of the Aid flow (current US$) in 1963 in Fragile and conflict affected situations to that in Heavily indebted poor countries?
Your answer should be very brief. 0.76. What is the difference between the highest and the second highest Aid flow (current US$) in 1960?
Your answer should be very brief. 0. What is the difference between the highest and the second highest Aid flow (current US$) in 1962?
Provide a succinct answer. 2.61e+06. What is the difference between the highest and the second highest Aid flow (current US$) in 1963?
Provide a succinct answer. 1.32e+07. What is the difference between the highest and the lowest Aid flow (current US$) in 1960?
Provide a succinct answer. 4.39e+07. What is the difference between the highest and the lowest Aid flow (current US$) in 1961?
Offer a very short reply. 1.81e+07. What is the difference between the highest and the lowest Aid flow (current US$) in 1962?
Provide a succinct answer. 5.90e+07. What is the difference between the highest and the lowest Aid flow (current US$) of 1963?
Provide a short and direct response. 3.72e+07. 